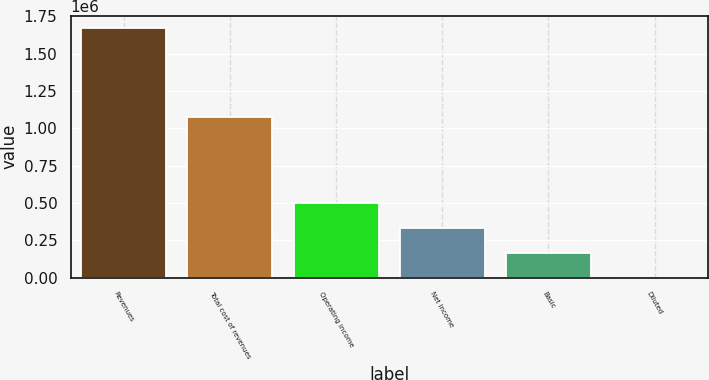Convert chart. <chart><loc_0><loc_0><loc_500><loc_500><bar_chart><fcel>Revenues<fcel>Total cost of revenues<fcel>Operating income<fcel>Net income<fcel>Basic<fcel>Diluted<nl><fcel>1.67027e+06<fcel>1.07927e+06<fcel>501082<fcel>334055<fcel>167029<fcel>1.98<nl></chart> 